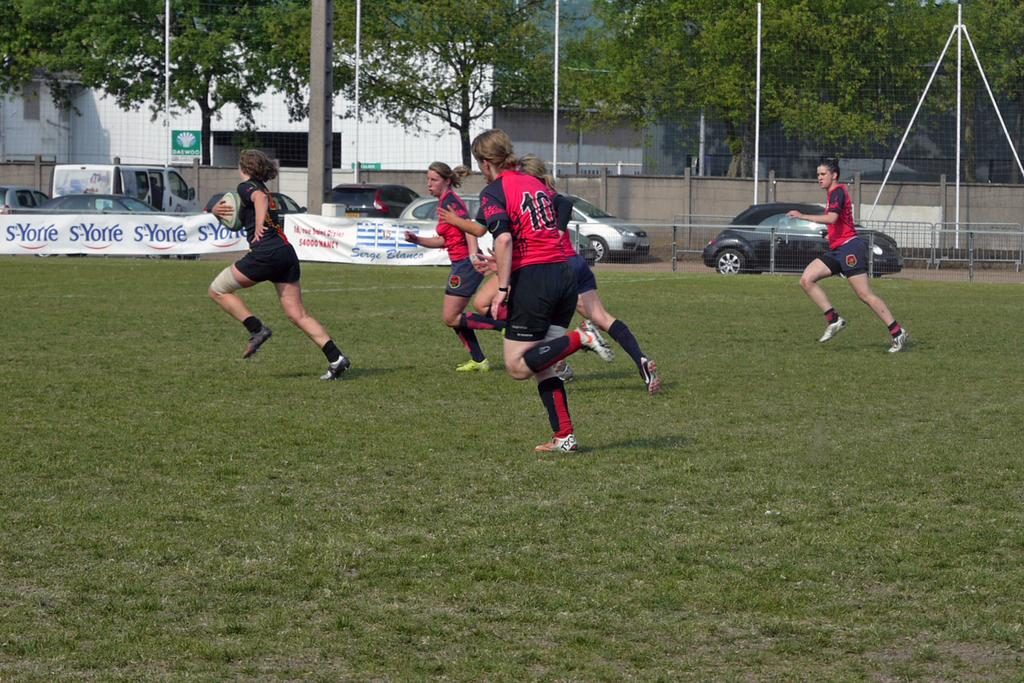What are the people in the image doing? The people in the image are running. What type of surface are the people running on? There is grass in the image, which suggests that the people are running on grass. What structures or objects can be seen in the image? There is a hoarding, a fence, poles, cars, trees, a wall, and a building visible in the image. What type of food is being attacked by a kite in the image? There is no food or kite present in the image. 